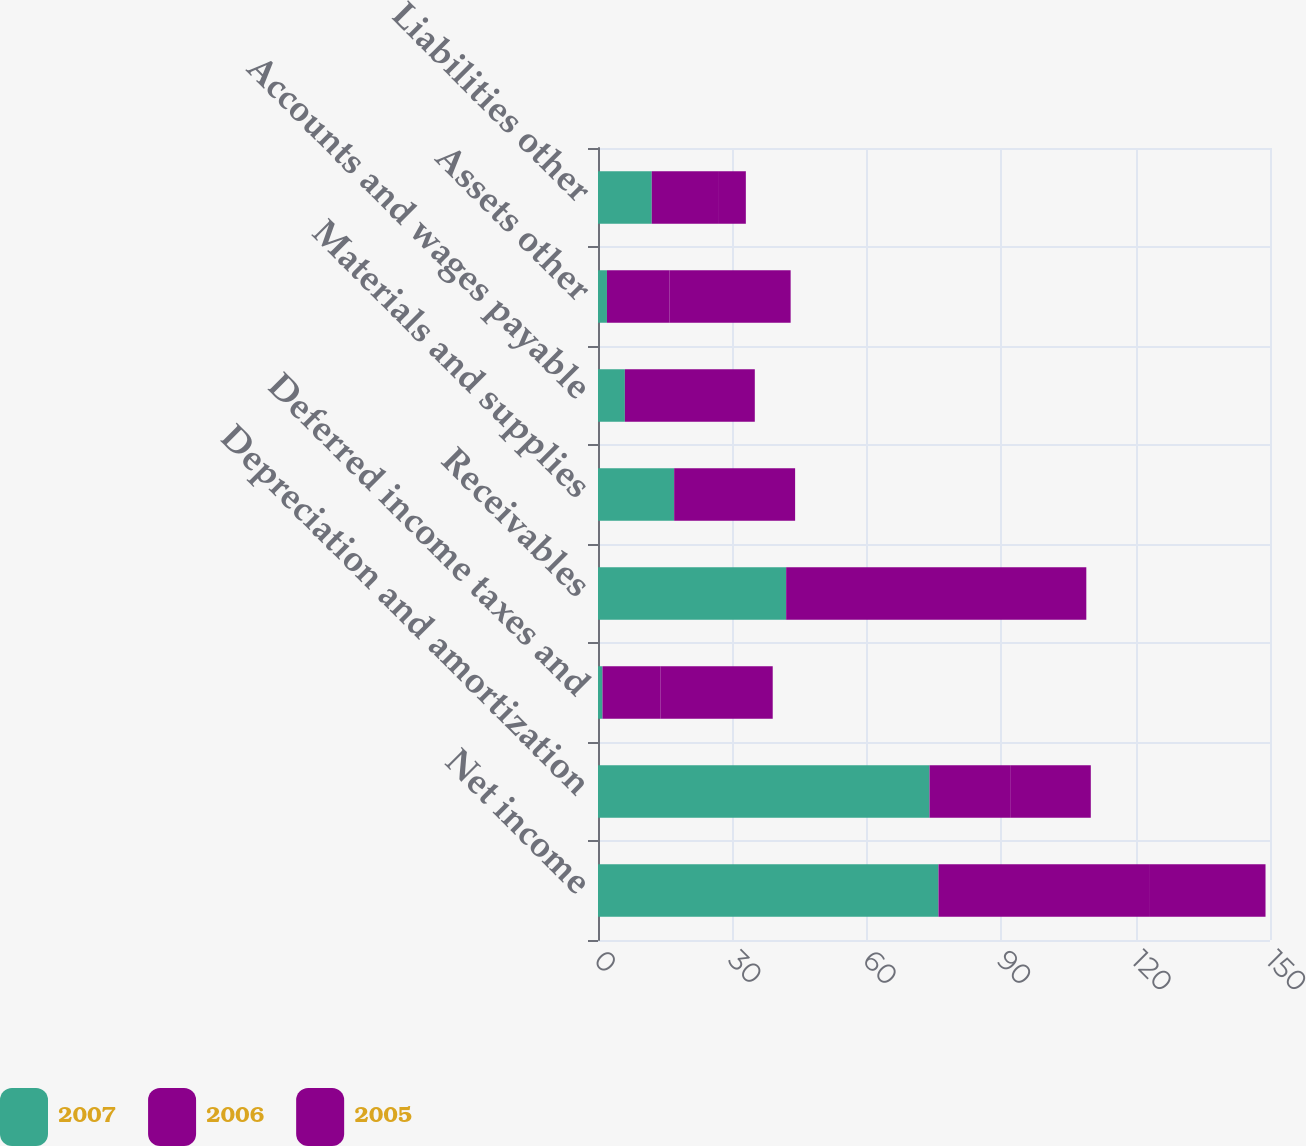Convert chart to OTSL. <chart><loc_0><loc_0><loc_500><loc_500><stacked_bar_chart><ecel><fcel>Net income<fcel>Depreciation and amortization<fcel>Deferred income taxes and<fcel>Receivables<fcel>Materials and supplies<fcel>Accounts and wages payable<fcel>Assets other<fcel>Liabilities other<nl><fcel>2007<fcel>76<fcel>74<fcel>1<fcel>42<fcel>17<fcel>6<fcel>2<fcel>12<nl><fcel>2006<fcel>47<fcel>18<fcel>13<fcel>33<fcel>8<fcel>19<fcel>14<fcel>15<nl><fcel>2005<fcel>26<fcel>18<fcel>25<fcel>34<fcel>19<fcel>10<fcel>27<fcel>6<nl></chart> 